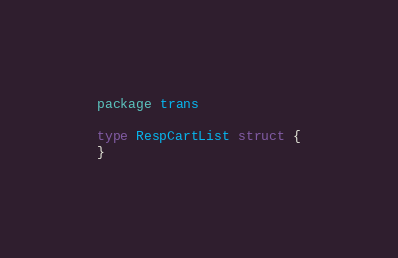<code> <loc_0><loc_0><loc_500><loc_500><_Go_>package trans

type RespCartList struct {
}
</code> 